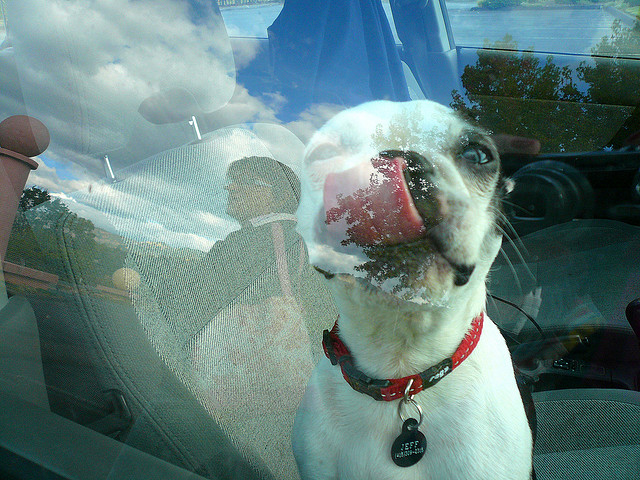Please transcribe the text information in this image. JEFF 